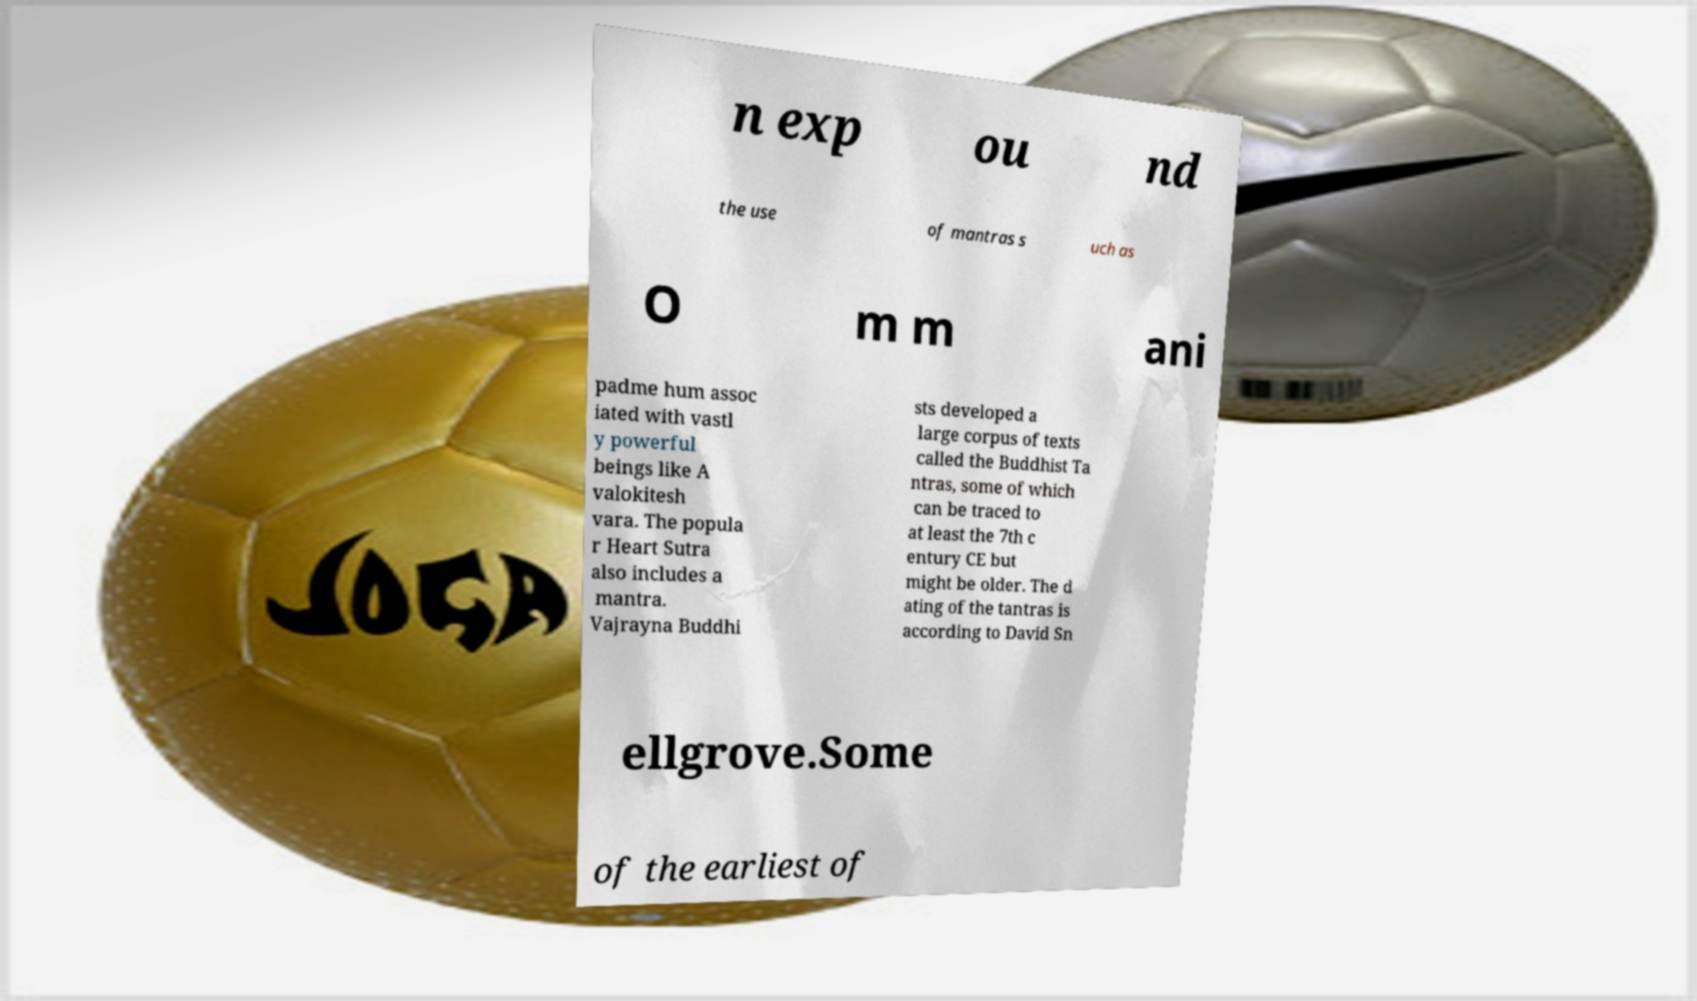Could you extract and type out the text from this image? n exp ou nd the use of mantras s uch as O m m ani padme hum assoc iated with vastl y powerful beings like A valokitesh vara. The popula r Heart Sutra also includes a mantra. Vajrayna Buddhi sts developed a large corpus of texts called the Buddhist Ta ntras, some of which can be traced to at least the 7th c entury CE but might be older. The d ating of the tantras is according to David Sn ellgrove.Some of the earliest of 